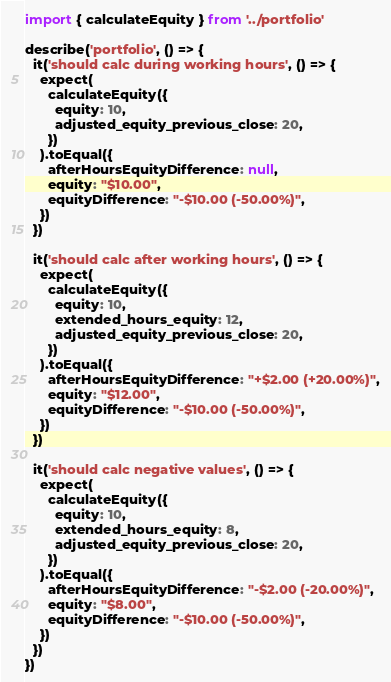Convert code to text. <code><loc_0><loc_0><loc_500><loc_500><_JavaScript_>
import { calculateEquity } from '../portfolio'

describe('portfolio', () => {
  it('should calc during working hours', () => {
    expect(
      calculateEquity({
        equity: 10,
        adjusted_equity_previous_close: 20,
      })
    ).toEqual({
      afterHoursEquityDifference: null,
      equity: "$10.00",
      equityDifference: "-$10.00 (-50.00%)",
    })
  })

  it('should calc after working hours', () => {
    expect(
      calculateEquity({
        equity: 10,
        extended_hours_equity: 12,
        adjusted_equity_previous_close: 20,
      })
    ).toEqual({
      afterHoursEquityDifference: "+$2.00 (+20.00%)",
      equity: "$12.00",
      equityDifference: "-$10.00 (-50.00%)",
    })
  })

  it('should calc negative values', () => {
    expect(
      calculateEquity({
        equity: 10,
        extended_hours_equity: 8,
        adjusted_equity_previous_close: 20,
      })
    ).toEqual({
      afterHoursEquityDifference: "-$2.00 (-20.00%)",
      equity: "$8.00",
      equityDifference: "-$10.00 (-50.00%)",
    })
  })
})
</code> 